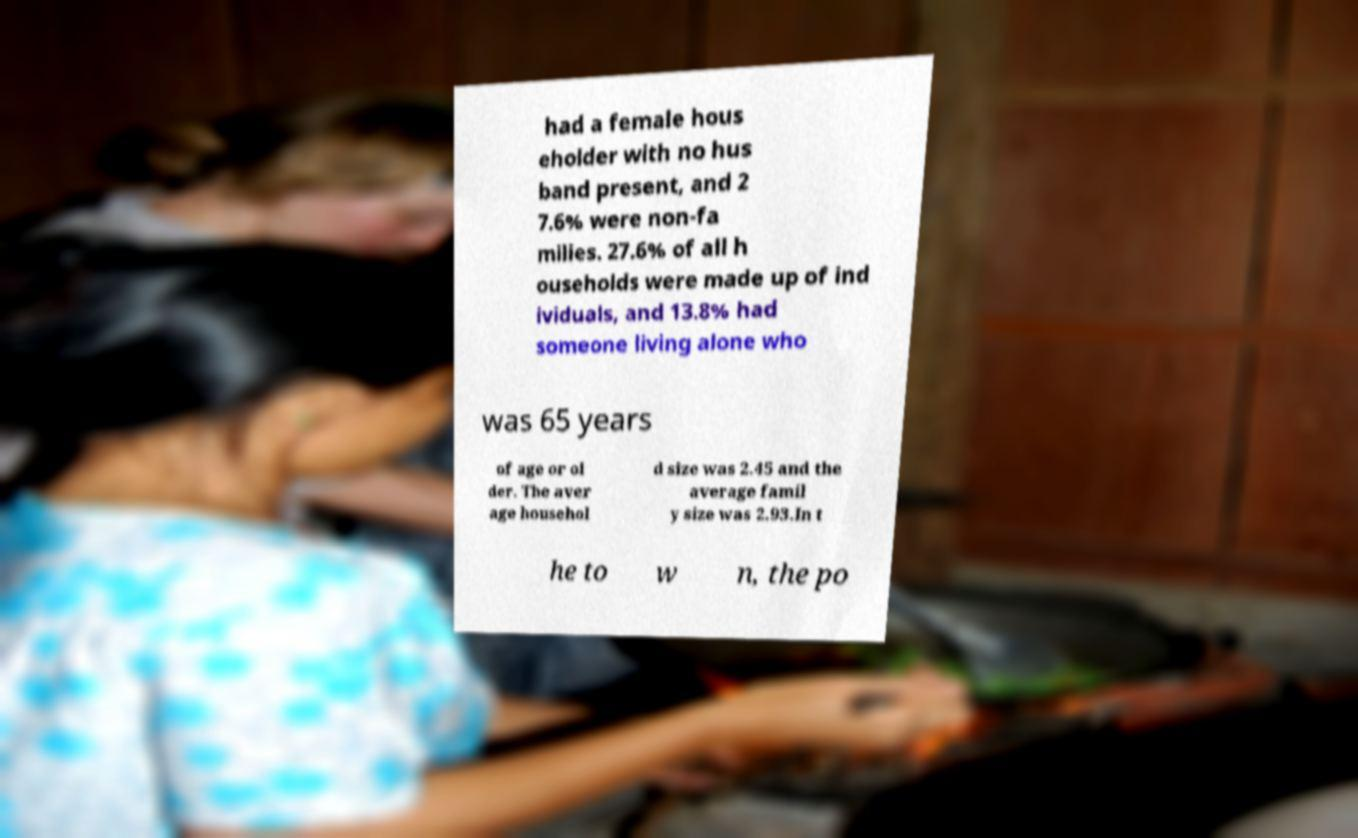Please identify and transcribe the text found in this image. had a female hous eholder with no hus band present, and 2 7.6% were non-fa milies. 27.6% of all h ouseholds were made up of ind ividuals, and 13.8% had someone living alone who was 65 years of age or ol der. The aver age househol d size was 2.45 and the average famil y size was 2.93.In t he to w n, the po 